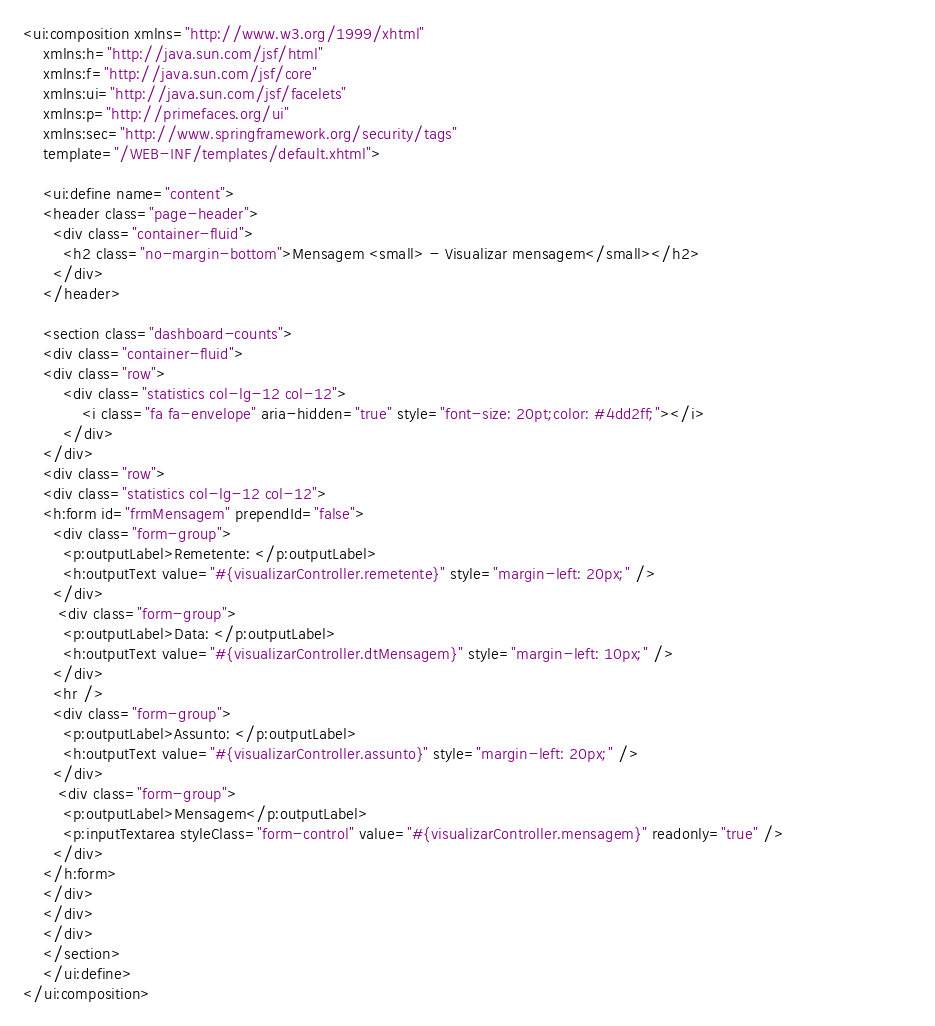<code> <loc_0><loc_0><loc_500><loc_500><_HTML_><ui:composition xmlns="http://www.w3.org/1999/xhtml"
	xmlns:h="http://java.sun.com/jsf/html"
    xmlns:f="http://java.sun.com/jsf/core"
    xmlns:ui="http://java.sun.com/jsf/facelets"
	xmlns:p="http://primefaces.org/ui"
	xmlns:sec="http://www.springframework.org/security/tags"
	template="/WEB-INF/templates/default.xhtml">

	<ui:define name="content">
	<header class="page-header">
      <div class="container-fluid">
        <h2 class="no-margin-bottom">Mensagem <small> - Visualizar mensagem</small></h2>   
      </div>
    </header>
    
    <section class="dashboard-counts">
    <div class="container-fluid">
    <div class="row">
    	<div class="statistics col-lg-12 col-12">
    		<i class="fa fa-envelope" aria-hidden="true" style="font-size: 20pt;color: #4dd2ff;"></i>
    	</div>
    </div>
    <div class="row">
    <div class="statistics col-lg-12 col-12">
    <h:form id="frmMensagem" prependId="false">
      <div class="form-group">
        <p:outputLabel>Remetente: </p:outputLabel>
 		<h:outputText value="#{visualizarController.remetente}" style="margin-left: 20px;" />
	  </div>
	   <div class="form-group">
        <p:outputLabel>Data: </p:outputLabel>
 		<h:outputText value="#{visualizarController.dtMensagem}" style="margin-left: 10px;" />
	  </div>
	  <hr />
	  <div class="form-group">
        <p:outputLabel>Assunto: </p:outputLabel>
 		<h:outputText value="#{visualizarController.assunto}" style="margin-left: 20px;" />
	  </div>
	   <div class="form-group">
	    <p:outputLabel>Mensagem</p:outputLabel>
	    <p:inputTextarea styleClass="form-control" value="#{visualizarController.mensagem}" readonly="true" />						  
	  </div>
    </h:form>
    </div>
    </div>
	</div>
	</section>
	</ui:define>
</ui:composition></code> 